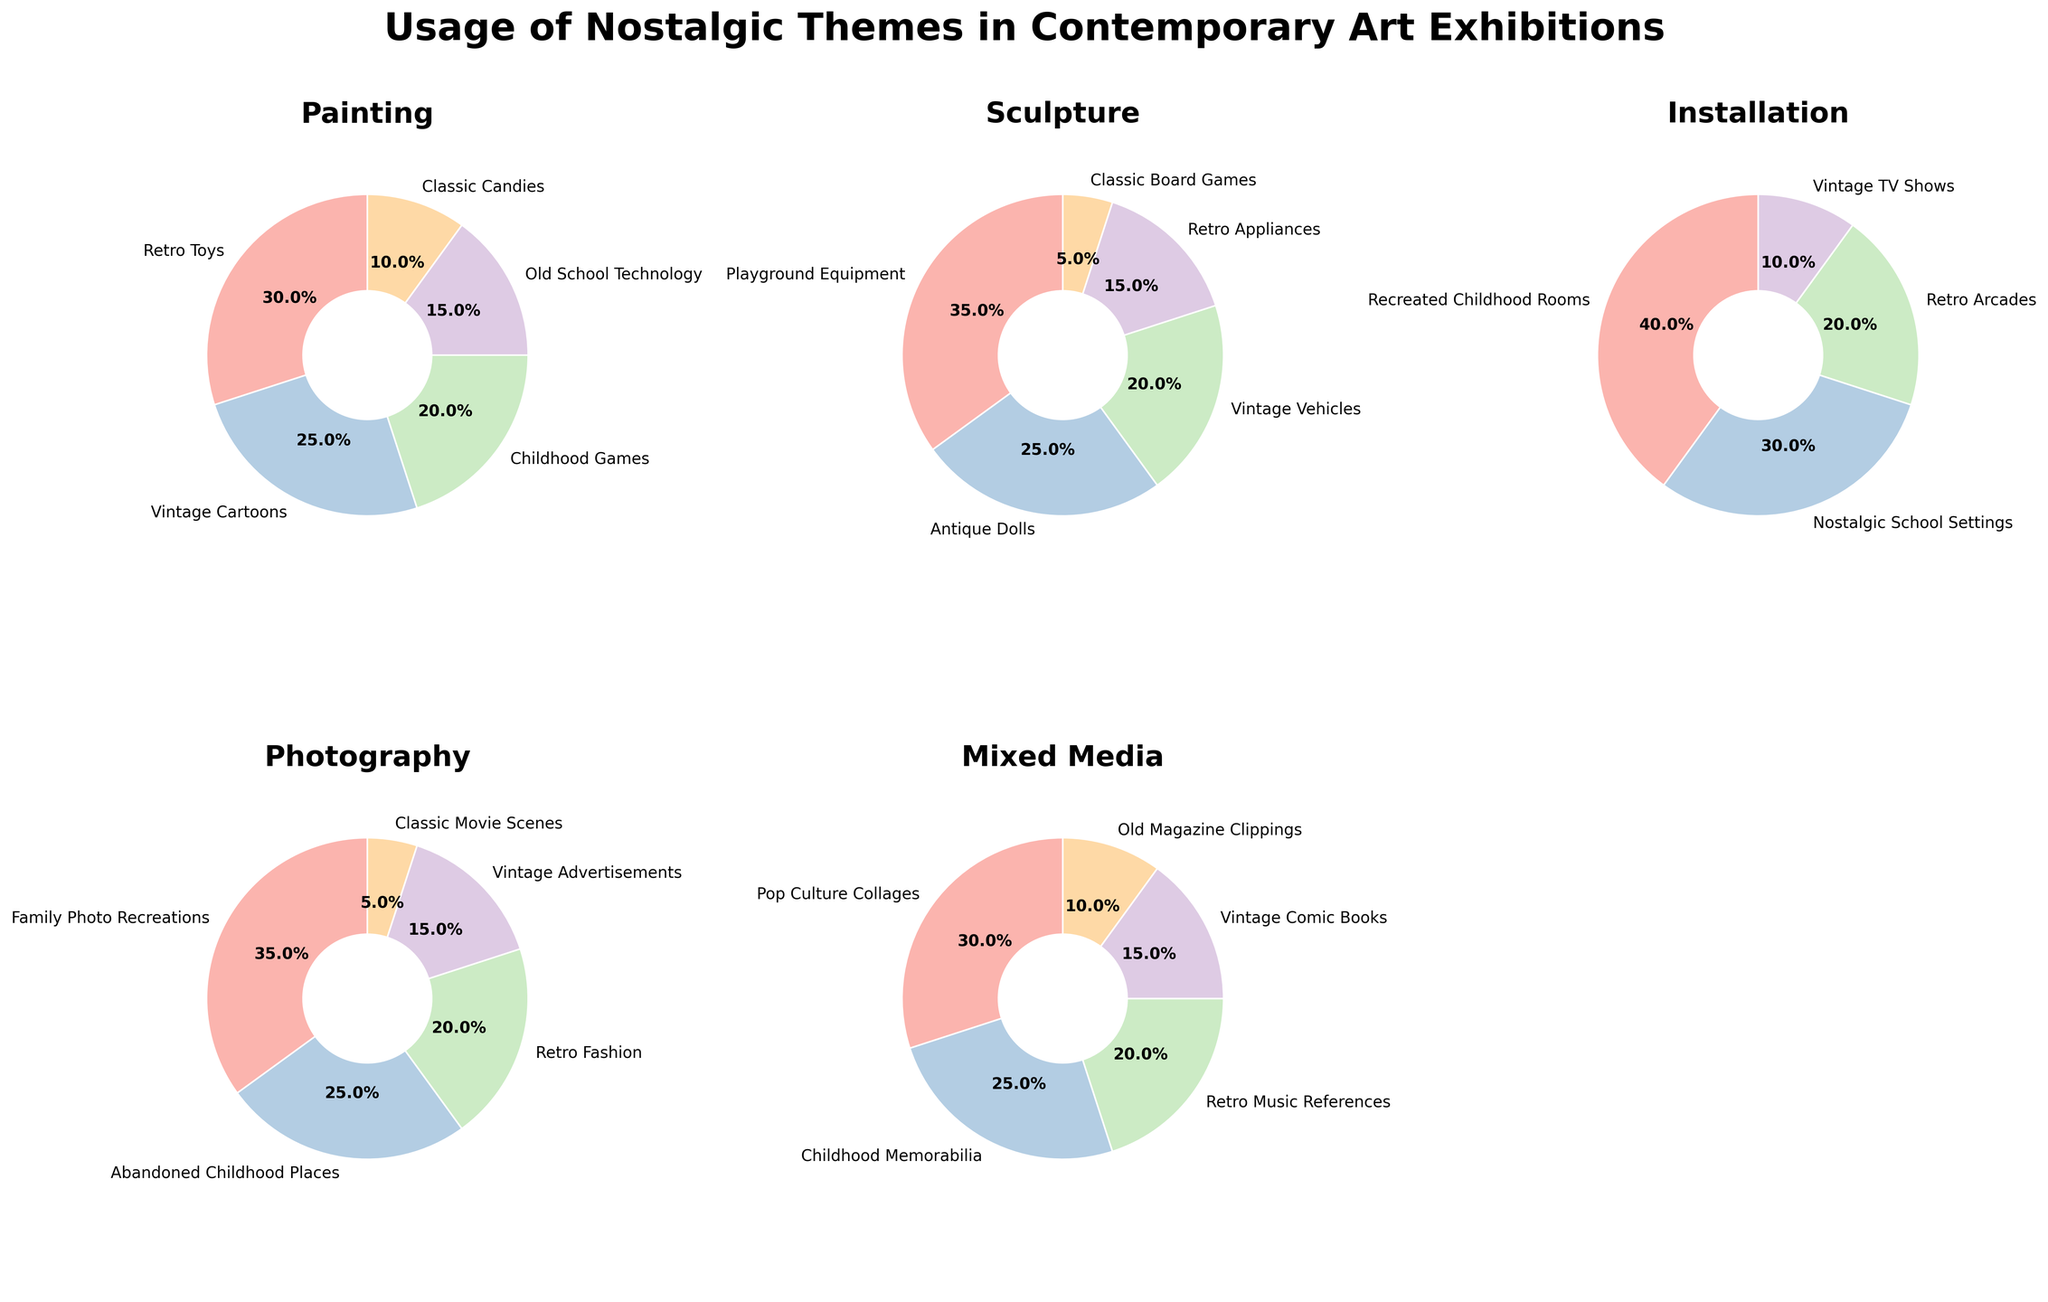Which category has the theme with the highest percentage? The theme "Recreated Childhood Rooms" under the "Installation" category has the highest percentage at 40%.
Answer: Installation What is the combined percentage of themes related to "Vintage" across all categories? Add the percentages of all "Vintage"-related themes: "Vintage Cartoons" (25) + "Vintage Vehicles" (20) + "Vintage TV Shows" (10) + "Vintage Advertisements" (15) + "Vintage Comic Books" (15) = 85%.
Answer: 85% Which category dedicates the smallest percentage to a single theme, and what is that theme? "Sculpture" dedicates the smallest percentage to a single theme, which is "Classic Board Games" at 5%.
Answer: Sculpture, Classic Board Games Compare the percentage of "Retro Toys" in Painting to "Retro Fashion" in Photography. Which one is higher? "Retro Toys" in Painting has a percentage of 30%, while "Retro Fashion" in Photography has a percentage of 20%. Therefore, "Retro Toys" is higher.
Answer: Retro Toys How many categories have at least one theme with a percentage of 35% or higher? The categories "Sculpture" and "Photography" each have one theme with at least 35% ("Playground Equipment" in Sculpture and "Family Photo Recreations" in Photography). The category "Installation" also has "Recreated Childhood Rooms" at 40%. Thus, 3 categories meet the criterion.
Answer: 3 What is the average percentage of themes in the "Mixed Media" category? The percentages in "Mixed Media" are: 30, 25, 20, 15, 10. Summing these, we get 30 + 25 + 20 + 15 + 10 = 100. Dividing by the number of themes (5), the average percentage is 100/5 = 20%.
Answer: 20% In the "Painting" category, by how much does the percentage of "Retro Toys" exceed that of "Classic Candies"? "Retro Toys" has a percentage of 30%, and "Classic Candies" has a percentage of 10%. The difference is 30 - 10 = 20 percentage points.
Answer: 20 percentage points Which theme in the "Installation" category has the smallest percentage, and what is it? The theme "Vintage TV Shows" in the "Installation" category has the smallest percentage at 10%.
Answer: Vintage TV Shows What is the sum of the percentages for "Installation" themes "Recreated Childhood Rooms" and "Nostalgic School Settings"? The percentage for "Recreated Childhood Rooms" is 40%, and for "Nostalgic School Settings" it is 30%. The sum is 40 + 30 = 70%.
Answer: 70% 